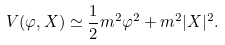<formula> <loc_0><loc_0><loc_500><loc_500>V ( \varphi , X ) \simeq \frac { 1 } { 2 } m ^ { 2 } \varphi ^ { 2 } + m ^ { 2 } | X | ^ { 2 } .</formula> 